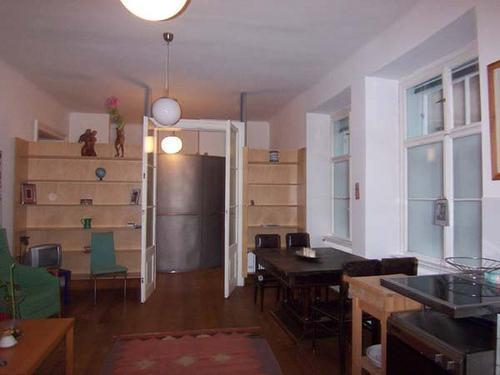How many lights are shown in the picture?
Give a very brief answer. 1. How many chairs are in the room?
Give a very brief answer. 6. How many chairs are visible?
Give a very brief answer. 2. 